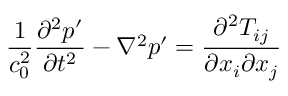<formula> <loc_0><loc_0><loc_500><loc_500>\frac { 1 } { c _ { 0 } ^ { 2 } } \frac { \partial ^ { 2 } p ^ { \prime } } { \partial t ^ { 2 } } - \nabla ^ { 2 } p ^ { \prime } = \frac { \partial ^ { 2 } T _ { i j } } { \partial x _ { i } \partial x _ { j } }</formula> 